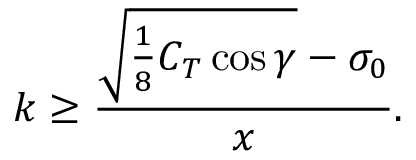Convert formula to latex. <formula><loc_0><loc_0><loc_500><loc_500>k \geq \frac { \sqrt { \frac { 1 } { 8 } C _ { T } \cos { \gamma } } - \sigma _ { 0 } } { x } .</formula> 